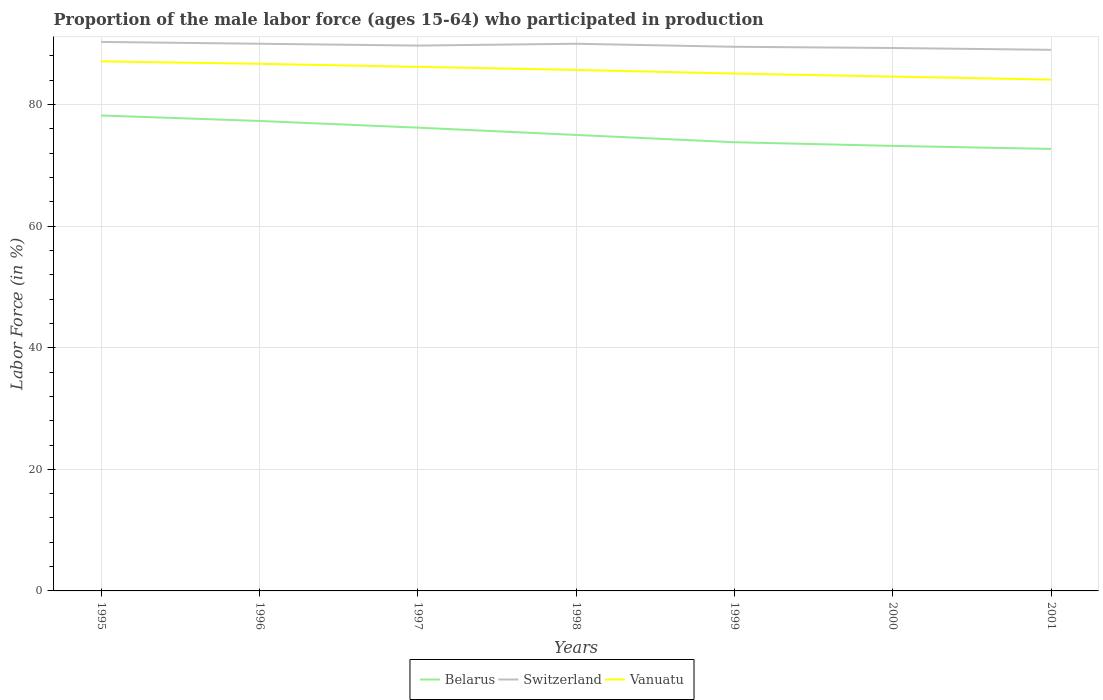How many different coloured lines are there?
Provide a short and direct response. 3. Is the number of lines equal to the number of legend labels?
Offer a terse response. Yes. Across all years, what is the maximum proportion of the male labor force who participated in production in Switzerland?
Make the answer very short. 89. In which year was the proportion of the male labor force who participated in production in Belarus maximum?
Your answer should be very brief. 2001. What is the total proportion of the male labor force who participated in production in Switzerland in the graph?
Offer a very short reply. 0.6. What is the difference between the highest and the second highest proportion of the male labor force who participated in production in Switzerland?
Make the answer very short. 1.3. What is the difference between the highest and the lowest proportion of the male labor force who participated in production in Switzerland?
Provide a short and direct response. 4. Is the proportion of the male labor force who participated in production in Belarus strictly greater than the proportion of the male labor force who participated in production in Vanuatu over the years?
Your answer should be compact. Yes. How many years are there in the graph?
Offer a terse response. 7. Are the values on the major ticks of Y-axis written in scientific E-notation?
Provide a short and direct response. No. Does the graph contain any zero values?
Your answer should be very brief. No. Does the graph contain grids?
Provide a short and direct response. Yes. How many legend labels are there?
Your answer should be compact. 3. What is the title of the graph?
Your answer should be compact. Proportion of the male labor force (ages 15-64) who participated in production. What is the label or title of the Y-axis?
Give a very brief answer. Labor Force (in %). What is the Labor Force (in %) in Belarus in 1995?
Offer a terse response. 78.2. What is the Labor Force (in %) of Switzerland in 1995?
Offer a very short reply. 90.3. What is the Labor Force (in %) in Vanuatu in 1995?
Ensure brevity in your answer.  87.1. What is the Labor Force (in %) in Belarus in 1996?
Make the answer very short. 77.3. What is the Labor Force (in %) of Switzerland in 1996?
Provide a short and direct response. 90. What is the Labor Force (in %) in Vanuatu in 1996?
Your answer should be very brief. 86.7. What is the Labor Force (in %) of Belarus in 1997?
Offer a terse response. 76.2. What is the Labor Force (in %) of Switzerland in 1997?
Make the answer very short. 89.7. What is the Labor Force (in %) of Vanuatu in 1997?
Ensure brevity in your answer.  86.2. What is the Labor Force (in %) in Vanuatu in 1998?
Provide a short and direct response. 85.7. What is the Labor Force (in %) of Belarus in 1999?
Provide a short and direct response. 73.8. What is the Labor Force (in %) of Switzerland in 1999?
Give a very brief answer. 89.5. What is the Labor Force (in %) of Vanuatu in 1999?
Offer a very short reply. 85.1. What is the Labor Force (in %) of Belarus in 2000?
Make the answer very short. 73.2. What is the Labor Force (in %) in Switzerland in 2000?
Your answer should be very brief. 89.3. What is the Labor Force (in %) in Vanuatu in 2000?
Give a very brief answer. 84.6. What is the Labor Force (in %) in Belarus in 2001?
Your response must be concise. 72.7. What is the Labor Force (in %) of Switzerland in 2001?
Your answer should be very brief. 89. What is the Labor Force (in %) of Vanuatu in 2001?
Keep it short and to the point. 84.1. Across all years, what is the maximum Labor Force (in %) in Belarus?
Your answer should be very brief. 78.2. Across all years, what is the maximum Labor Force (in %) of Switzerland?
Ensure brevity in your answer.  90.3. Across all years, what is the maximum Labor Force (in %) in Vanuatu?
Ensure brevity in your answer.  87.1. Across all years, what is the minimum Labor Force (in %) of Belarus?
Provide a succinct answer. 72.7. Across all years, what is the minimum Labor Force (in %) of Switzerland?
Your response must be concise. 89. Across all years, what is the minimum Labor Force (in %) in Vanuatu?
Offer a very short reply. 84.1. What is the total Labor Force (in %) in Belarus in the graph?
Ensure brevity in your answer.  526.4. What is the total Labor Force (in %) of Switzerland in the graph?
Make the answer very short. 627.8. What is the total Labor Force (in %) in Vanuatu in the graph?
Provide a short and direct response. 599.5. What is the difference between the Labor Force (in %) in Switzerland in 1995 and that in 1998?
Offer a terse response. 0.3. What is the difference between the Labor Force (in %) in Switzerland in 1995 and that in 1999?
Your answer should be very brief. 0.8. What is the difference between the Labor Force (in %) in Vanuatu in 1995 and that in 2000?
Your response must be concise. 2.5. What is the difference between the Labor Force (in %) of Belarus in 1995 and that in 2001?
Ensure brevity in your answer.  5.5. What is the difference between the Labor Force (in %) of Switzerland in 1995 and that in 2001?
Offer a terse response. 1.3. What is the difference between the Labor Force (in %) of Vanuatu in 1995 and that in 2001?
Your answer should be very brief. 3. What is the difference between the Labor Force (in %) of Vanuatu in 1996 and that in 1997?
Provide a short and direct response. 0.5. What is the difference between the Labor Force (in %) of Switzerland in 1996 and that in 1998?
Provide a succinct answer. 0. What is the difference between the Labor Force (in %) in Vanuatu in 1996 and that in 1998?
Offer a terse response. 1. What is the difference between the Labor Force (in %) of Belarus in 1996 and that in 1999?
Offer a very short reply. 3.5. What is the difference between the Labor Force (in %) of Switzerland in 1996 and that in 1999?
Your response must be concise. 0.5. What is the difference between the Labor Force (in %) in Belarus in 1996 and that in 2000?
Provide a succinct answer. 4.1. What is the difference between the Labor Force (in %) of Belarus in 1996 and that in 2001?
Your response must be concise. 4.6. What is the difference between the Labor Force (in %) in Switzerland in 1996 and that in 2001?
Keep it short and to the point. 1. What is the difference between the Labor Force (in %) in Belarus in 1997 and that in 1999?
Ensure brevity in your answer.  2.4. What is the difference between the Labor Force (in %) of Belarus in 1997 and that in 2000?
Your response must be concise. 3. What is the difference between the Labor Force (in %) in Switzerland in 1998 and that in 2000?
Give a very brief answer. 0.7. What is the difference between the Labor Force (in %) of Vanuatu in 1998 and that in 2000?
Ensure brevity in your answer.  1.1. What is the difference between the Labor Force (in %) of Belarus in 1998 and that in 2001?
Provide a succinct answer. 2.3. What is the difference between the Labor Force (in %) in Vanuatu in 1998 and that in 2001?
Make the answer very short. 1.6. What is the difference between the Labor Force (in %) of Belarus in 1999 and that in 2000?
Ensure brevity in your answer.  0.6. What is the difference between the Labor Force (in %) in Switzerland in 1999 and that in 2000?
Offer a very short reply. 0.2. What is the difference between the Labor Force (in %) of Vanuatu in 1999 and that in 2000?
Keep it short and to the point. 0.5. What is the difference between the Labor Force (in %) of Belarus in 2000 and that in 2001?
Offer a very short reply. 0.5. What is the difference between the Labor Force (in %) of Switzerland in 2000 and that in 2001?
Ensure brevity in your answer.  0.3. What is the difference between the Labor Force (in %) of Belarus in 1995 and the Labor Force (in %) of Switzerland in 1996?
Offer a very short reply. -11.8. What is the difference between the Labor Force (in %) of Switzerland in 1995 and the Labor Force (in %) of Vanuatu in 1996?
Give a very brief answer. 3.6. What is the difference between the Labor Force (in %) of Belarus in 1995 and the Labor Force (in %) of Vanuatu in 1997?
Keep it short and to the point. -8. What is the difference between the Labor Force (in %) of Switzerland in 1995 and the Labor Force (in %) of Vanuatu in 1997?
Offer a terse response. 4.1. What is the difference between the Labor Force (in %) of Switzerland in 1995 and the Labor Force (in %) of Vanuatu in 1998?
Ensure brevity in your answer.  4.6. What is the difference between the Labor Force (in %) of Belarus in 1995 and the Labor Force (in %) of Switzerland in 1999?
Ensure brevity in your answer.  -11.3. What is the difference between the Labor Force (in %) of Belarus in 1995 and the Labor Force (in %) of Vanuatu in 1999?
Offer a terse response. -6.9. What is the difference between the Labor Force (in %) of Switzerland in 1995 and the Labor Force (in %) of Vanuatu in 1999?
Ensure brevity in your answer.  5.2. What is the difference between the Labor Force (in %) of Belarus in 1995 and the Labor Force (in %) of Switzerland in 2000?
Provide a short and direct response. -11.1. What is the difference between the Labor Force (in %) in Belarus in 1995 and the Labor Force (in %) in Vanuatu in 2000?
Make the answer very short. -6.4. What is the difference between the Labor Force (in %) in Belarus in 1995 and the Labor Force (in %) in Vanuatu in 2001?
Provide a short and direct response. -5.9. What is the difference between the Labor Force (in %) of Switzerland in 1995 and the Labor Force (in %) of Vanuatu in 2001?
Give a very brief answer. 6.2. What is the difference between the Labor Force (in %) of Belarus in 1996 and the Labor Force (in %) of Vanuatu in 1997?
Offer a very short reply. -8.9. What is the difference between the Labor Force (in %) of Switzerland in 1996 and the Labor Force (in %) of Vanuatu in 1997?
Your answer should be compact. 3.8. What is the difference between the Labor Force (in %) of Belarus in 1996 and the Labor Force (in %) of Switzerland in 1998?
Your answer should be very brief. -12.7. What is the difference between the Labor Force (in %) in Belarus in 1996 and the Labor Force (in %) in Switzerland in 1999?
Give a very brief answer. -12.2. What is the difference between the Labor Force (in %) of Belarus in 1996 and the Labor Force (in %) of Vanuatu in 1999?
Your answer should be compact. -7.8. What is the difference between the Labor Force (in %) in Switzerland in 1996 and the Labor Force (in %) in Vanuatu in 1999?
Offer a terse response. 4.9. What is the difference between the Labor Force (in %) of Switzerland in 1996 and the Labor Force (in %) of Vanuatu in 2000?
Offer a terse response. 5.4. What is the difference between the Labor Force (in %) in Belarus in 1996 and the Labor Force (in %) in Vanuatu in 2001?
Your answer should be compact. -6.8. What is the difference between the Labor Force (in %) of Switzerland in 1997 and the Labor Force (in %) of Vanuatu in 1999?
Provide a short and direct response. 4.6. What is the difference between the Labor Force (in %) in Belarus in 1997 and the Labor Force (in %) in Switzerland in 2000?
Offer a very short reply. -13.1. What is the difference between the Labor Force (in %) in Switzerland in 1998 and the Labor Force (in %) in Vanuatu in 1999?
Offer a terse response. 4.9. What is the difference between the Labor Force (in %) in Belarus in 1998 and the Labor Force (in %) in Switzerland in 2000?
Offer a very short reply. -14.3. What is the difference between the Labor Force (in %) of Belarus in 1998 and the Labor Force (in %) of Vanuatu in 2000?
Offer a terse response. -9.6. What is the difference between the Labor Force (in %) in Belarus in 1998 and the Labor Force (in %) in Vanuatu in 2001?
Provide a succinct answer. -9.1. What is the difference between the Labor Force (in %) of Belarus in 1999 and the Labor Force (in %) of Switzerland in 2000?
Your answer should be very brief. -15.5. What is the difference between the Labor Force (in %) in Belarus in 1999 and the Labor Force (in %) in Switzerland in 2001?
Provide a short and direct response. -15.2. What is the difference between the Labor Force (in %) in Belarus in 2000 and the Labor Force (in %) in Switzerland in 2001?
Your answer should be very brief. -15.8. What is the difference between the Labor Force (in %) in Switzerland in 2000 and the Labor Force (in %) in Vanuatu in 2001?
Provide a short and direct response. 5.2. What is the average Labor Force (in %) in Belarus per year?
Ensure brevity in your answer.  75.2. What is the average Labor Force (in %) in Switzerland per year?
Offer a terse response. 89.69. What is the average Labor Force (in %) in Vanuatu per year?
Keep it short and to the point. 85.64. In the year 1996, what is the difference between the Labor Force (in %) in Belarus and Labor Force (in %) in Switzerland?
Your response must be concise. -12.7. In the year 1996, what is the difference between the Labor Force (in %) of Switzerland and Labor Force (in %) of Vanuatu?
Provide a succinct answer. 3.3. In the year 1997, what is the difference between the Labor Force (in %) of Belarus and Labor Force (in %) of Vanuatu?
Make the answer very short. -10. In the year 1997, what is the difference between the Labor Force (in %) of Switzerland and Labor Force (in %) of Vanuatu?
Offer a very short reply. 3.5. In the year 1998, what is the difference between the Labor Force (in %) in Belarus and Labor Force (in %) in Vanuatu?
Offer a terse response. -10.7. In the year 1998, what is the difference between the Labor Force (in %) in Switzerland and Labor Force (in %) in Vanuatu?
Keep it short and to the point. 4.3. In the year 1999, what is the difference between the Labor Force (in %) of Belarus and Labor Force (in %) of Switzerland?
Make the answer very short. -15.7. In the year 1999, what is the difference between the Labor Force (in %) of Switzerland and Labor Force (in %) of Vanuatu?
Your response must be concise. 4.4. In the year 2000, what is the difference between the Labor Force (in %) in Belarus and Labor Force (in %) in Switzerland?
Provide a succinct answer. -16.1. In the year 2000, what is the difference between the Labor Force (in %) in Belarus and Labor Force (in %) in Vanuatu?
Your response must be concise. -11.4. In the year 2001, what is the difference between the Labor Force (in %) of Belarus and Labor Force (in %) of Switzerland?
Provide a succinct answer. -16.3. In the year 2001, what is the difference between the Labor Force (in %) in Belarus and Labor Force (in %) in Vanuatu?
Your answer should be compact. -11.4. What is the ratio of the Labor Force (in %) of Belarus in 1995 to that in 1996?
Your answer should be compact. 1.01. What is the ratio of the Labor Force (in %) of Switzerland in 1995 to that in 1996?
Make the answer very short. 1. What is the ratio of the Labor Force (in %) of Belarus in 1995 to that in 1997?
Keep it short and to the point. 1.03. What is the ratio of the Labor Force (in %) in Vanuatu in 1995 to that in 1997?
Your answer should be compact. 1.01. What is the ratio of the Labor Force (in %) of Belarus in 1995 to that in 1998?
Keep it short and to the point. 1.04. What is the ratio of the Labor Force (in %) in Switzerland in 1995 to that in 1998?
Ensure brevity in your answer.  1. What is the ratio of the Labor Force (in %) of Vanuatu in 1995 to that in 1998?
Your answer should be very brief. 1.02. What is the ratio of the Labor Force (in %) of Belarus in 1995 to that in 1999?
Offer a very short reply. 1.06. What is the ratio of the Labor Force (in %) of Switzerland in 1995 to that in 1999?
Provide a succinct answer. 1.01. What is the ratio of the Labor Force (in %) of Vanuatu in 1995 to that in 1999?
Your answer should be compact. 1.02. What is the ratio of the Labor Force (in %) in Belarus in 1995 to that in 2000?
Provide a succinct answer. 1.07. What is the ratio of the Labor Force (in %) in Switzerland in 1995 to that in 2000?
Your response must be concise. 1.01. What is the ratio of the Labor Force (in %) in Vanuatu in 1995 to that in 2000?
Offer a terse response. 1.03. What is the ratio of the Labor Force (in %) of Belarus in 1995 to that in 2001?
Offer a terse response. 1.08. What is the ratio of the Labor Force (in %) in Switzerland in 1995 to that in 2001?
Your response must be concise. 1.01. What is the ratio of the Labor Force (in %) of Vanuatu in 1995 to that in 2001?
Your answer should be compact. 1.04. What is the ratio of the Labor Force (in %) in Belarus in 1996 to that in 1997?
Offer a very short reply. 1.01. What is the ratio of the Labor Force (in %) of Switzerland in 1996 to that in 1997?
Your answer should be compact. 1. What is the ratio of the Labor Force (in %) of Vanuatu in 1996 to that in 1997?
Provide a short and direct response. 1.01. What is the ratio of the Labor Force (in %) of Belarus in 1996 to that in 1998?
Make the answer very short. 1.03. What is the ratio of the Labor Force (in %) of Switzerland in 1996 to that in 1998?
Your response must be concise. 1. What is the ratio of the Labor Force (in %) of Vanuatu in 1996 to that in 1998?
Your response must be concise. 1.01. What is the ratio of the Labor Force (in %) in Belarus in 1996 to that in 1999?
Keep it short and to the point. 1.05. What is the ratio of the Labor Force (in %) in Switzerland in 1996 to that in 1999?
Offer a very short reply. 1.01. What is the ratio of the Labor Force (in %) of Vanuatu in 1996 to that in 1999?
Make the answer very short. 1.02. What is the ratio of the Labor Force (in %) of Belarus in 1996 to that in 2000?
Provide a succinct answer. 1.06. What is the ratio of the Labor Force (in %) in Vanuatu in 1996 to that in 2000?
Keep it short and to the point. 1.02. What is the ratio of the Labor Force (in %) in Belarus in 1996 to that in 2001?
Keep it short and to the point. 1.06. What is the ratio of the Labor Force (in %) in Switzerland in 1996 to that in 2001?
Your answer should be very brief. 1.01. What is the ratio of the Labor Force (in %) of Vanuatu in 1996 to that in 2001?
Offer a very short reply. 1.03. What is the ratio of the Labor Force (in %) in Belarus in 1997 to that in 1998?
Give a very brief answer. 1.02. What is the ratio of the Labor Force (in %) of Switzerland in 1997 to that in 1998?
Your answer should be compact. 1. What is the ratio of the Labor Force (in %) of Belarus in 1997 to that in 1999?
Ensure brevity in your answer.  1.03. What is the ratio of the Labor Force (in %) of Switzerland in 1997 to that in 1999?
Make the answer very short. 1. What is the ratio of the Labor Force (in %) of Vanuatu in 1997 to that in 1999?
Provide a short and direct response. 1.01. What is the ratio of the Labor Force (in %) in Belarus in 1997 to that in 2000?
Offer a very short reply. 1.04. What is the ratio of the Labor Force (in %) in Vanuatu in 1997 to that in 2000?
Your answer should be very brief. 1.02. What is the ratio of the Labor Force (in %) in Belarus in 1997 to that in 2001?
Make the answer very short. 1.05. What is the ratio of the Labor Force (in %) in Switzerland in 1997 to that in 2001?
Offer a very short reply. 1.01. What is the ratio of the Labor Force (in %) of Vanuatu in 1997 to that in 2001?
Keep it short and to the point. 1.02. What is the ratio of the Labor Force (in %) of Belarus in 1998 to that in 1999?
Offer a very short reply. 1.02. What is the ratio of the Labor Force (in %) of Switzerland in 1998 to that in 1999?
Your answer should be compact. 1.01. What is the ratio of the Labor Force (in %) in Vanuatu in 1998 to that in 1999?
Keep it short and to the point. 1.01. What is the ratio of the Labor Force (in %) of Belarus in 1998 to that in 2000?
Your answer should be very brief. 1.02. What is the ratio of the Labor Force (in %) in Switzerland in 1998 to that in 2000?
Your answer should be very brief. 1.01. What is the ratio of the Labor Force (in %) of Belarus in 1998 to that in 2001?
Make the answer very short. 1.03. What is the ratio of the Labor Force (in %) of Switzerland in 1998 to that in 2001?
Provide a short and direct response. 1.01. What is the ratio of the Labor Force (in %) of Belarus in 1999 to that in 2000?
Ensure brevity in your answer.  1.01. What is the ratio of the Labor Force (in %) in Vanuatu in 1999 to that in 2000?
Keep it short and to the point. 1.01. What is the ratio of the Labor Force (in %) of Belarus in 1999 to that in 2001?
Offer a terse response. 1.02. What is the ratio of the Labor Force (in %) in Switzerland in 1999 to that in 2001?
Offer a very short reply. 1.01. What is the ratio of the Labor Force (in %) of Vanuatu in 1999 to that in 2001?
Your response must be concise. 1.01. What is the ratio of the Labor Force (in %) in Vanuatu in 2000 to that in 2001?
Make the answer very short. 1.01. What is the difference between the highest and the second highest Labor Force (in %) of Vanuatu?
Your answer should be compact. 0.4. What is the difference between the highest and the lowest Labor Force (in %) of Belarus?
Provide a short and direct response. 5.5. 